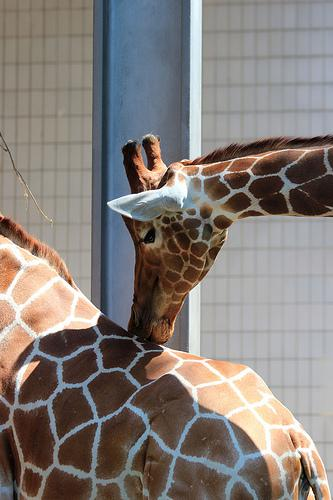Question: what animal is in the photo?
Choices:
A. Giraffe.
B. Dog.
C. Monkey.
D. Lion.
Answer with the letter. Answer: A Question: how many giraffes are in the photo?
Choices:
A. Three.
B. Two.
C. Four.
D. Five.
Answer with the letter. Answer: B Question: when was the photo taken?
Choices:
A. After dinner.
B. Afternoon.
C. Morning.
D. Bedtime.
Answer with the letter. Answer: B Question: where was the photo taken?
Choices:
A. Zoo.
B. Circus.
C. Park.
D. Hallway.
Answer with the letter. Answer: A 